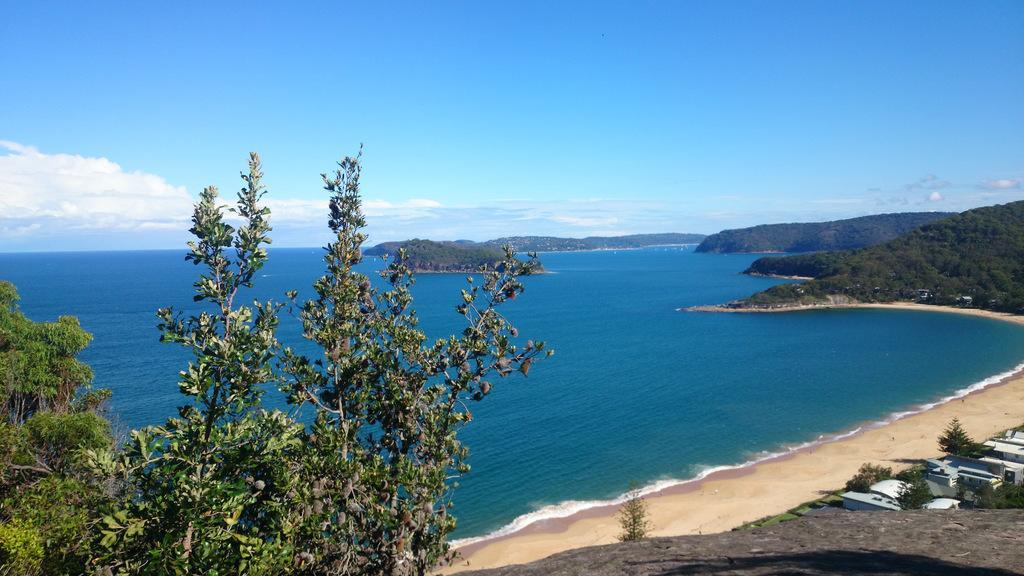Could you give a brief overview of what you see in this image? In this image we can see water. Also there are trees. On the right there are buildings. In the background there is sky with clouds. 